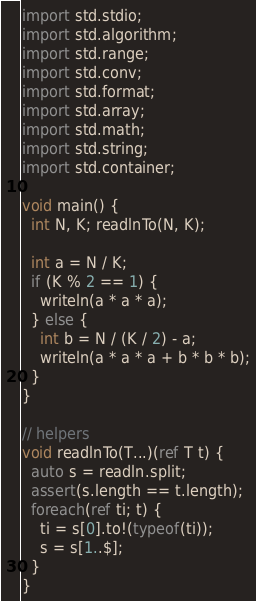<code> <loc_0><loc_0><loc_500><loc_500><_D_>import std.stdio;
import std.algorithm;
import std.range;
import std.conv;
import std.format;
import std.array;
import std.math;
import std.string;
import std.container;

void main() {
  int N, K; readlnTo(N, K);

  int a = N / K;
  if (K % 2 == 1) {
    writeln(a * a * a);
  } else {
    int b = N / (K / 2) - a;
    writeln(a * a * a + b * b * b);
  }
}

// helpers
void readlnTo(T...)(ref T t) {
  auto s = readln.split;
  assert(s.length == t.length);
  foreach(ref ti; t) {
    ti = s[0].to!(typeof(ti));
    s = s[1..$];
  }
}
</code> 